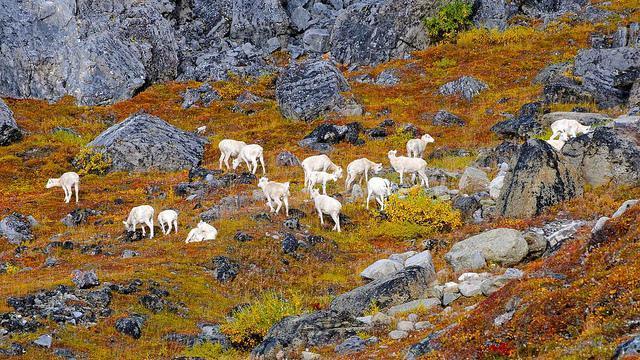How many animals are laying down?
Give a very brief answer. 1. 